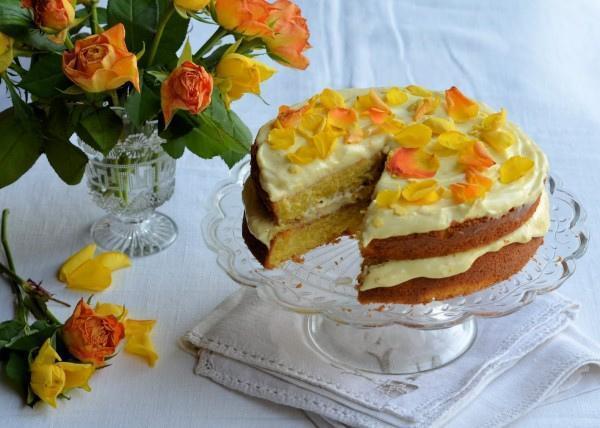How many desserts are on the doily?
Give a very brief answer. 1. How many women are in this photo?
Give a very brief answer. 0. 